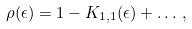Convert formula to latex. <formula><loc_0><loc_0><loc_500><loc_500>\rho ( \epsilon ) = 1 - K _ { 1 , 1 } ( \epsilon ) + \dots \, ,</formula> 